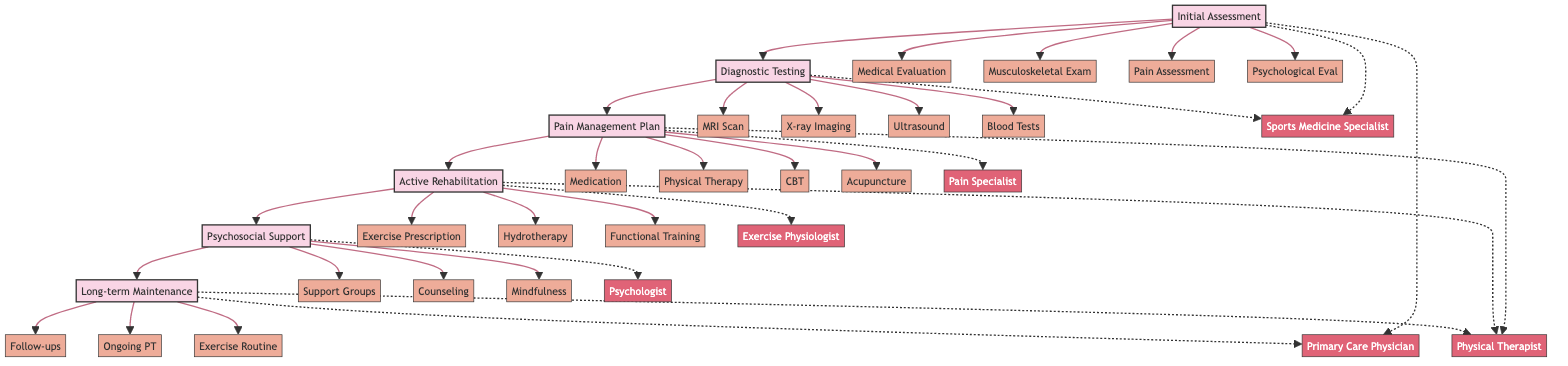What is the first stage of the pathway? The first stage listed in the diagram is "Initial Assessment." This is identified as the starting point before moving on to subsequent stages.
Answer: Initial Assessment How many components are there in the Pain Management Plan stage? In the Pain Management Plan stage, there are five components: Medication Management, Physical Therapy, Cognitive Behavioral Therapy (CBT), Acupuncture, and Manual Therapy. Thus, the total is five.
Answer: 5 Which provider is associated with the Diagnostic Testing stage? The providers for the Diagnostic Testing stage are the Radiologist and the Laboratory Technician. Either can represent the involvement of professionals in this stage, highlighting their essential roles.
Answer: Radiologist, Laboratory Technician What components are included in the Active Rehabilitation stage? The Active Rehabilitation stage includes Exercise Prescription, Hydrotherapy, Functional Training, and Strength and Condition Training. These components are critical for a tailored rehabilitation approach to chronic pain management.
Answer: Exercise Prescription, Hydrotherapy, Functional Training, Strength and Condition Training What is the last stage of the pathway? The last stage in the pathway is "Long-term Maintenance." This indicates that the pathway ends with ongoing support and treatment measures to manage chronic pain effectively.
Answer: Long-term Maintenance Who provides individual counseling in the Psychosocial Support stage? In the Psychosocial Support stage, the provider responsible for individual counseling is the Mental Health Counselor. This role focuses on providing psychological support and guidance.
Answer: Mental Health Counselor How many stages are present in the diagram? The diagram includes six distinct stages: Initial Assessment, Diagnostic Testing, Pain Management Plan, Active Rehabilitation, Psychosocial Support, and Long-term Maintenance. Hence, the total number of stages is six.
Answer: 6 Which component of the Pain Management Plan involves therapy? The component in the Pain Management Plan that involves therapy is "Cognitive Behavioral Therapy (CBT)." This specifically addresses psychological aspects of pain management.
Answer: Cognitive Behavioral Therapy (CBT) What type of testing is included in the Diagnostic Testing stage? The Diagnostic Testing stage includes MRI Scan, X-ray Imaging, Ultrasound, and Blood Tests. These testing types are critical in diagnosing the underlying causes of pain.
Answer: MRI Scan, X-ray Imaging, Ultrasound, Blood Tests 